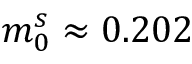Convert formula to latex. <formula><loc_0><loc_0><loc_500><loc_500>m _ { 0 } ^ { s } \approx 0 . 2 0 2</formula> 